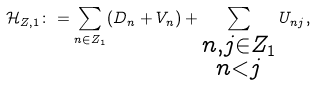<formula> <loc_0><loc_0><loc_500><loc_500>\mathcal { H } _ { Z , 1 } \colon = \sum _ { n \in Z _ { 1 } } ( D _ { n } + V _ { n } ) + \sum _ { \substack { n , j \in Z _ { 1 } \\ n < j } } U _ { n j } ,</formula> 